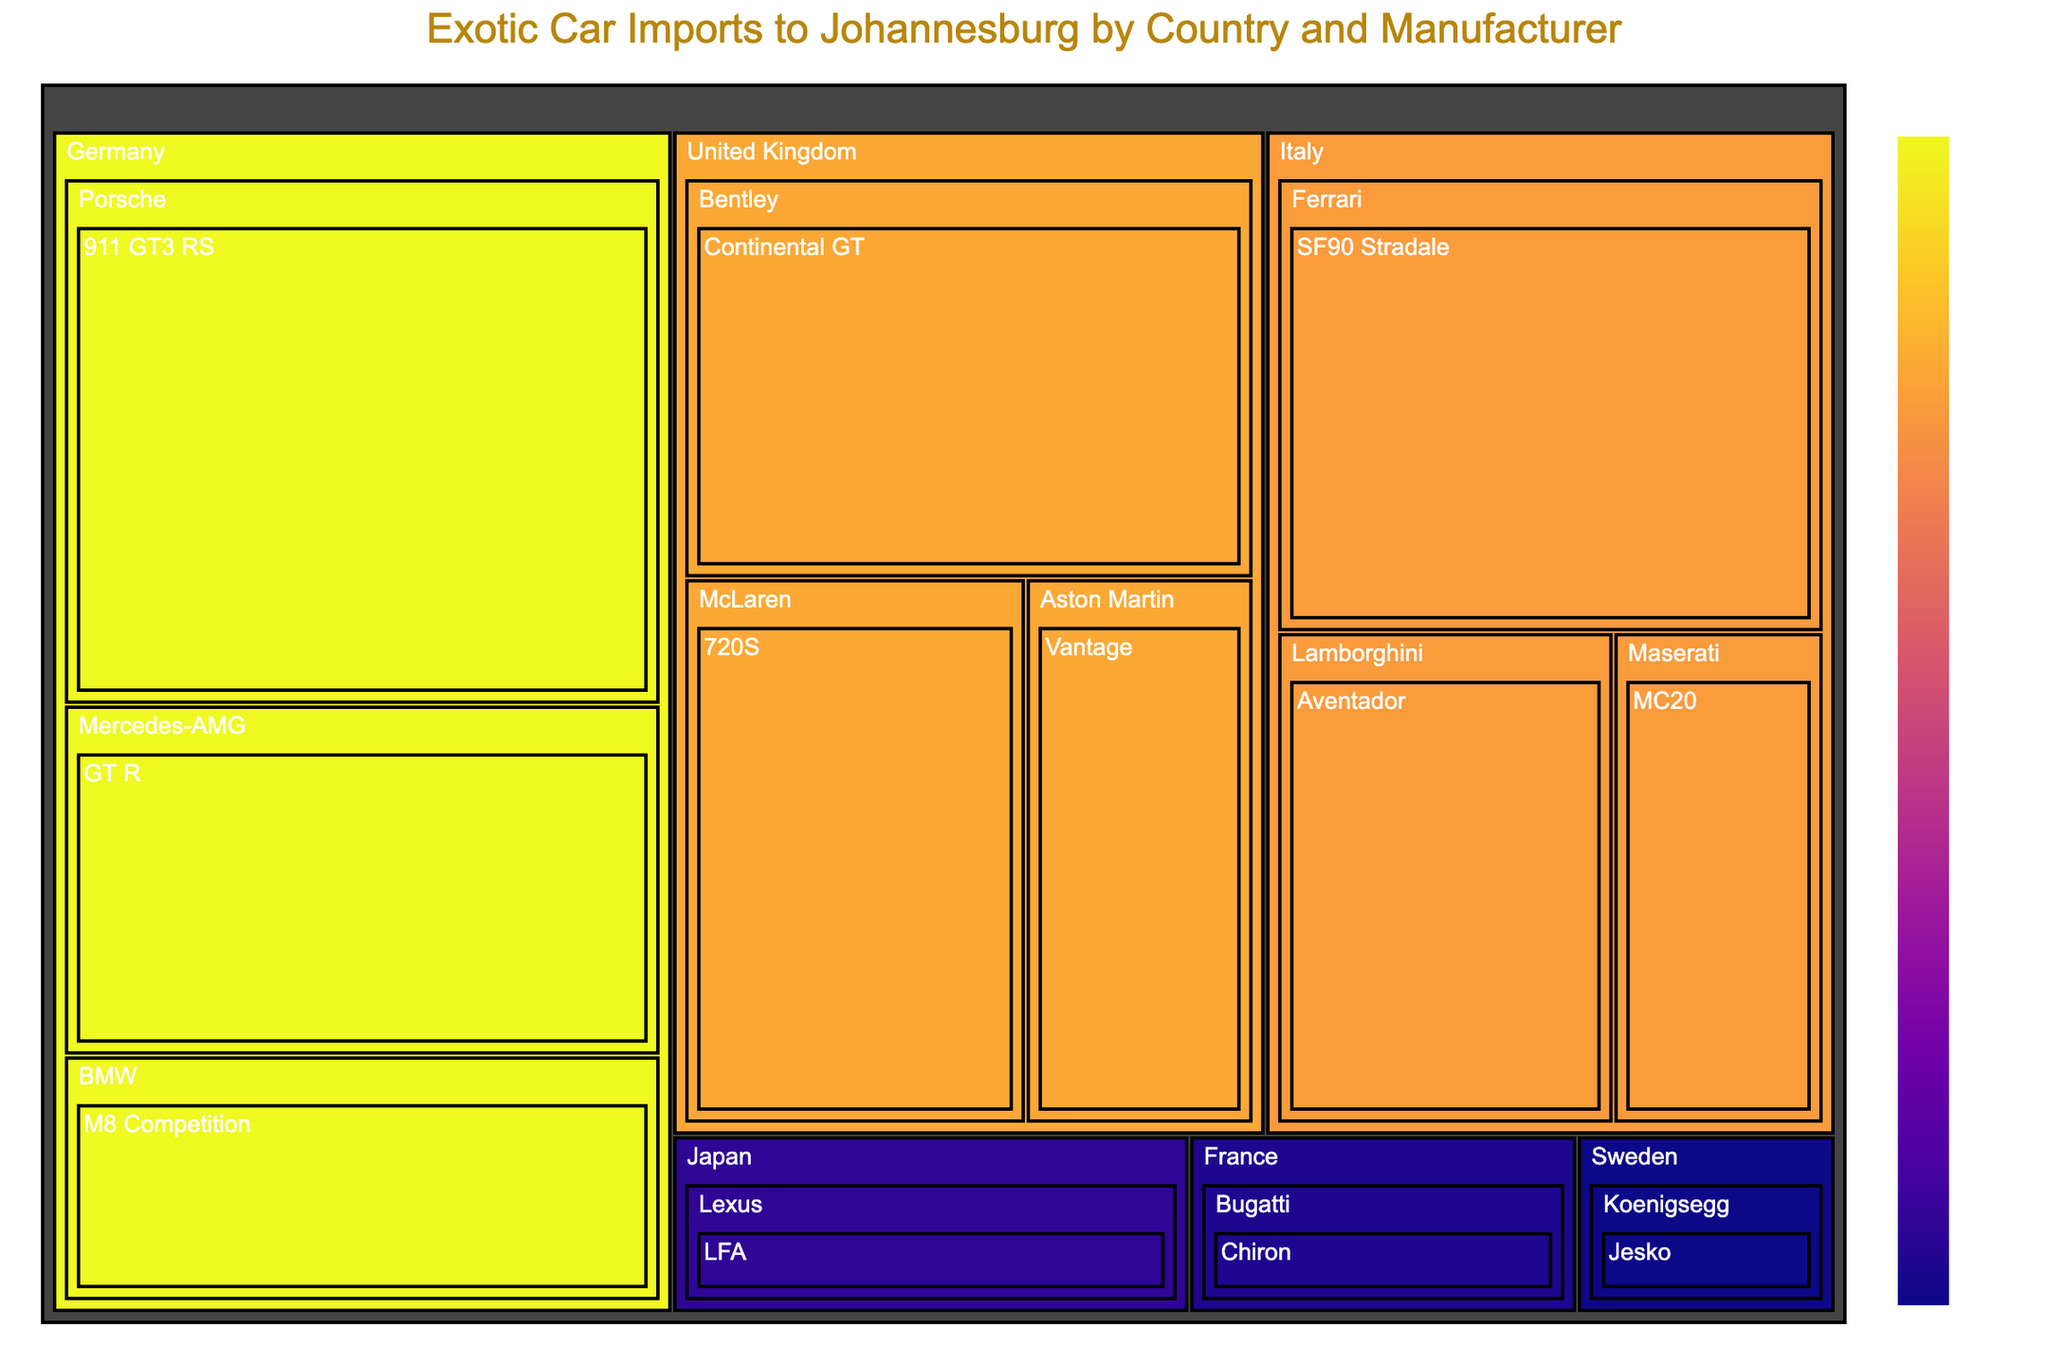what is the title of the figure? The title is typically placed at the top of the figure. It provides the main topic or the context of the entire visual representation, in this case, relating to exotic car imports to Johannesburg.
Answer: Exotic Car Imports to Johannesburg by Country and Manufacturer How many total units of Ferrari vehicles were imported? The Treemap shows a breakdown by country, manufacturer, and model. Under Italy, the model breakdown for Ferrari (SF90 Stradale) would provide this number directly.
Answer: 12 Which country has the highest total units of exotic car imports? By looking at the largest box or by the color scaling, we can see which country stands out with the highest total units. In this case, it’s Germany as German manufacturers like Porsche and Mercedes-AMG combined have the most units.
Answer: Germany What is the difference in units between the Lamborghini Aventador and the Maserati MC20? Find the values corresponding to Lamborghini Aventador and Maserati MC20 under Italy. Lamborghini Aventador has 8 units, and Maserati MC20 has 5 units. The difference is calculated as 8 - 5.
Answer: 3 Which manufacturer's model has the fewest number of units imported? Look for the smallest individual box in the Treemap. The smallest box represents the model with the fewest units. In this case, it's the Koenigsegg Jesko from Sweden with 2 units.
Answer: Koenigsegg Jesko Among the cars imported from the United Kingdom, which manufacturer has the most units? Look at the sub-boxes under the United Kingdom. Bentley, with its Continental GT model, appears to have the most units.
Answer: Bentley How many total models are shown in the Treemap? Each box at the lowest hierarchy level represents a model. By counting these boxes, you determine the total number of models. There are models from Ferrari, Lamborghini, Maserati, Porsche, Mercedes-AMG, BMW, Aston Martin, McLaren, Bentley, Koenigsegg, Bugatti, and Lexus.
Answer: 12 How do the imports of luxury cars from France and Sweden compare? Comparing the total units for France and Sweden, the Treemap shows that Bugatti from France had 3 units, while Koenigsegg from Sweden had 2 units. Thus, France had 1 more unit than Sweden.
Answer: France has 1 more unit What is the total number of units imported from Italy? Sum the units for all models under Italy: Ferrari (12), Lamborghini (8), and Maserati (5). The total is 12 + 8 + 5.
Answer: 25 Which model has the highest number of units imported overall? Check for the largest individual box or the one with the largest number associated with it. The Porsche 911 GT3 RS from Germany has the highest number with 15 units.
Answer: Porsche 911 GT3 RS 